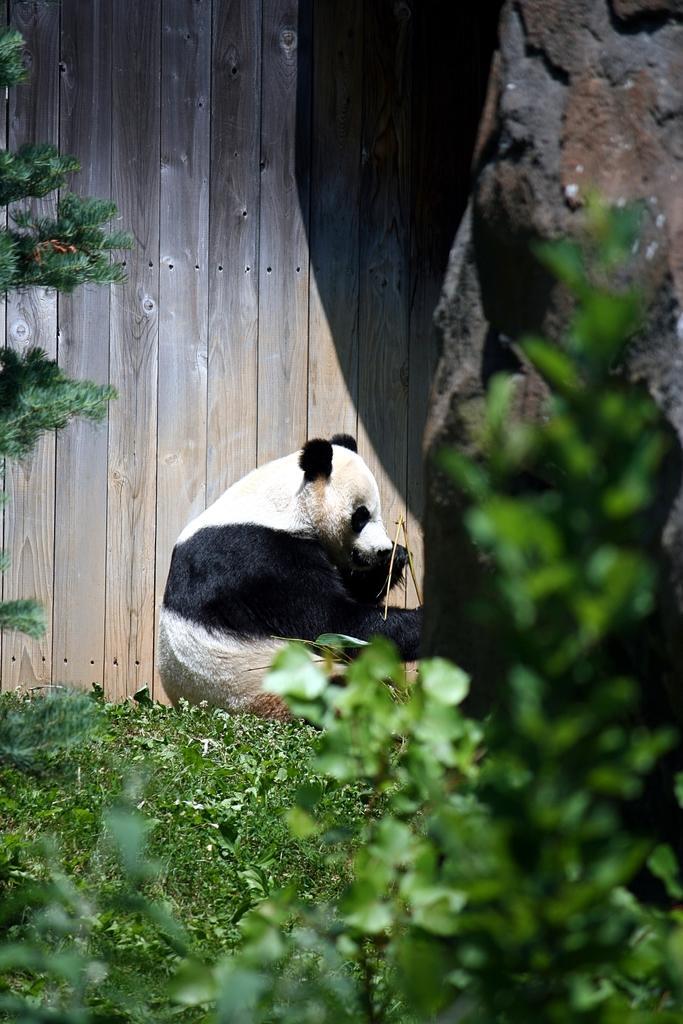How would you summarize this image in a sentence or two? In the center of the image we can see panda sitting on the grass. In the background there is wooden wall. On the right side of the image we can see plants. 